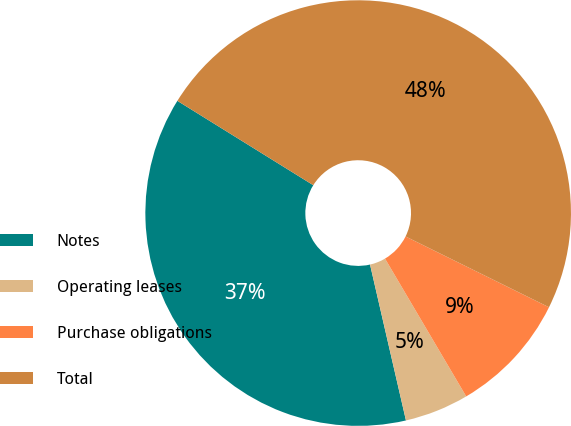<chart> <loc_0><loc_0><loc_500><loc_500><pie_chart><fcel>Notes<fcel>Operating leases<fcel>Purchase obligations<fcel>Total<nl><fcel>37.45%<fcel>4.87%<fcel>9.23%<fcel>48.46%<nl></chart> 